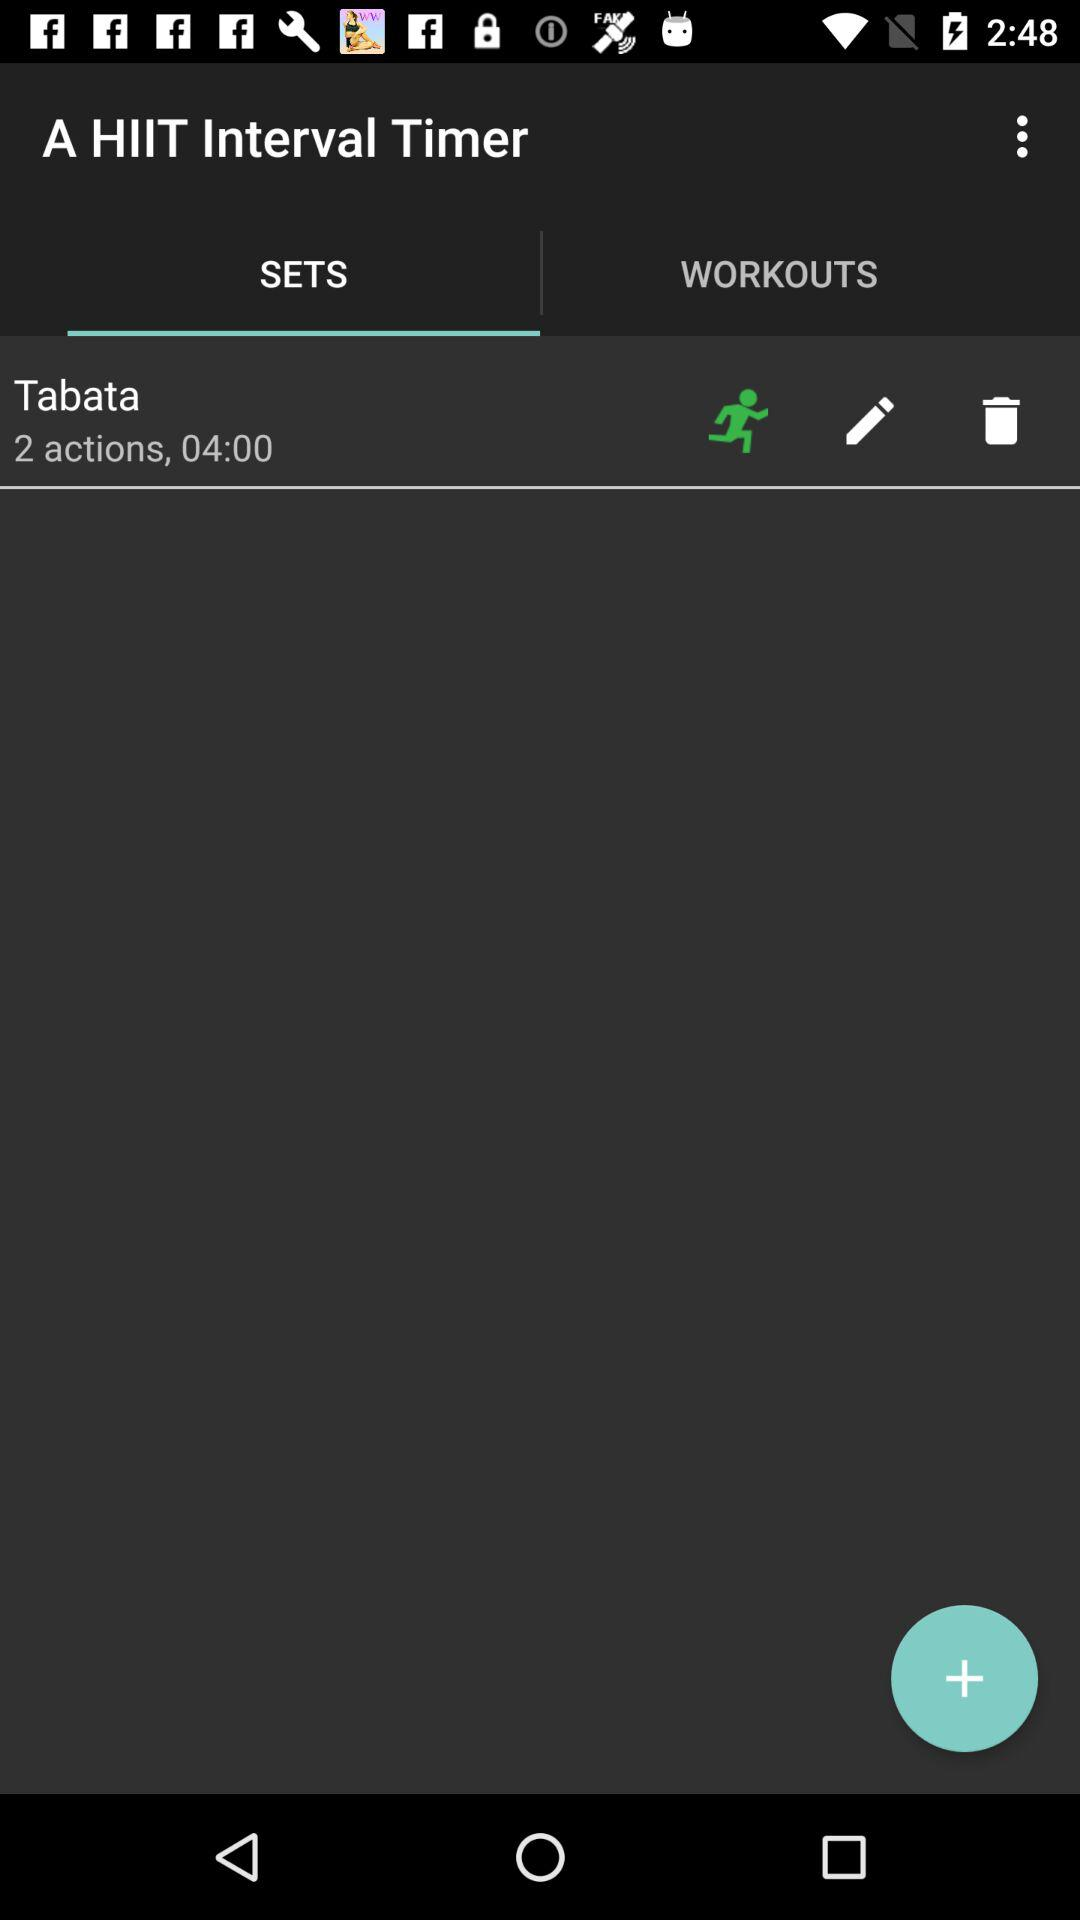How long is the workout?
Answer the question using a single word or phrase. 04:00 